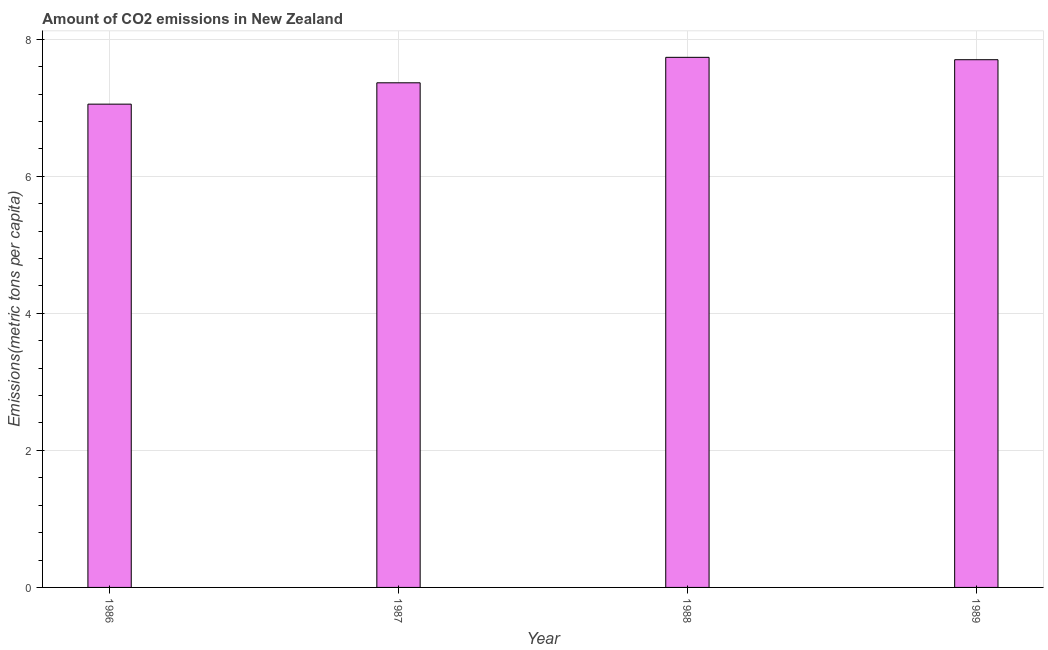What is the title of the graph?
Offer a very short reply. Amount of CO2 emissions in New Zealand. What is the label or title of the Y-axis?
Offer a terse response. Emissions(metric tons per capita). What is the amount of co2 emissions in 1989?
Keep it short and to the point. 7.7. Across all years, what is the maximum amount of co2 emissions?
Your response must be concise. 7.74. Across all years, what is the minimum amount of co2 emissions?
Your answer should be compact. 7.05. What is the sum of the amount of co2 emissions?
Your answer should be compact. 29.85. What is the difference between the amount of co2 emissions in 1986 and 1987?
Provide a succinct answer. -0.31. What is the average amount of co2 emissions per year?
Your answer should be very brief. 7.46. What is the median amount of co2 emissions?
Make the answer very short. 7.53. In how many years, is the amount of co2 emissions greater than 6.8 metric tons per capita?
Give a very brief answer. 4. Do a majority of the years between 1986 and 1989 (inclusive) have amount of co2 emissions greater than 2.8 metric tons per capita?
Make the answer very short. Yes. What is the ratio of the amount of co2 emissions in 1986 to that in 1989?
Give a very brief answer. 0.92. Is the difference between the amount of co2 emissions in 1988 and 1989 greater than the difference between any two years?
Give a very brief answer. No. What is the difference between the highest and the second highest amount of co2 emissions?
Make the answer very short. 0.04. What is the difference between the highest and the lowest amount of co2 emissions?
Your response must be concise. 0.68. In how many years, is the amount of co2 emissions greater than the average amount of co2 emissions taken over all years?
Provide a short and direct response. 2. How many bars are there?
Your answer should be compact. 4. What is the Emissions(metric tons per capita) in 1986?
Provide a succinct answer. 7.05. What is the Emissions(metric tons per capita) in 1987?
Provide a short and direct response. 7.36. What is the Emissions(metric tons per capita) in 1988?
Keep it short and to the point. 7.74. What is the Emissions(metric tons per capita) in 1989?
Offer a very short reply. 7.7. What is the difference between the Emissions(metric tons per capita) in 1986 and 1987?
Offer a terse response. -0.31. What is the difference between the Emissions(metric tons per capita) in 1986 and 1988?
Ensure brevity in your answer.  -0.68. What is the difference between the Emissions(metric tons per capita) in 1986 and 1989?
Ensure brevity in your answer.  -0.65. What is the difference between the Emissions(metric tons per capita) in 1987 and 1988?
Offer a very short reply. -0.37. What is the difference between the Emissions(metric tons per capita) in 1987 and 1989?
Your answer should be compact. -0.34. What is the difference between the Emissions(metric tons per capita) in 1988 and 1989?
Ensure brevity in your answer.  0.03. What is the ratio of the Emissions(metric tons per capita) in 1986 to that in 1987?
Ensure brevity in your answer.  0.96. What is the ratio of the Emissions(metric tons per capita) in 1986 to that in 1988?
Give a very brief answer. 0.91. What is the ratio of the Emissions(metric tons per capita) in 1986 to that in 1989?
Ensure brevity in your answer.  0.92. What is the ratio of the Emissions(metric tons per capita) in 1987 to that in 1989?
Your answer should be compact. 0.96. 